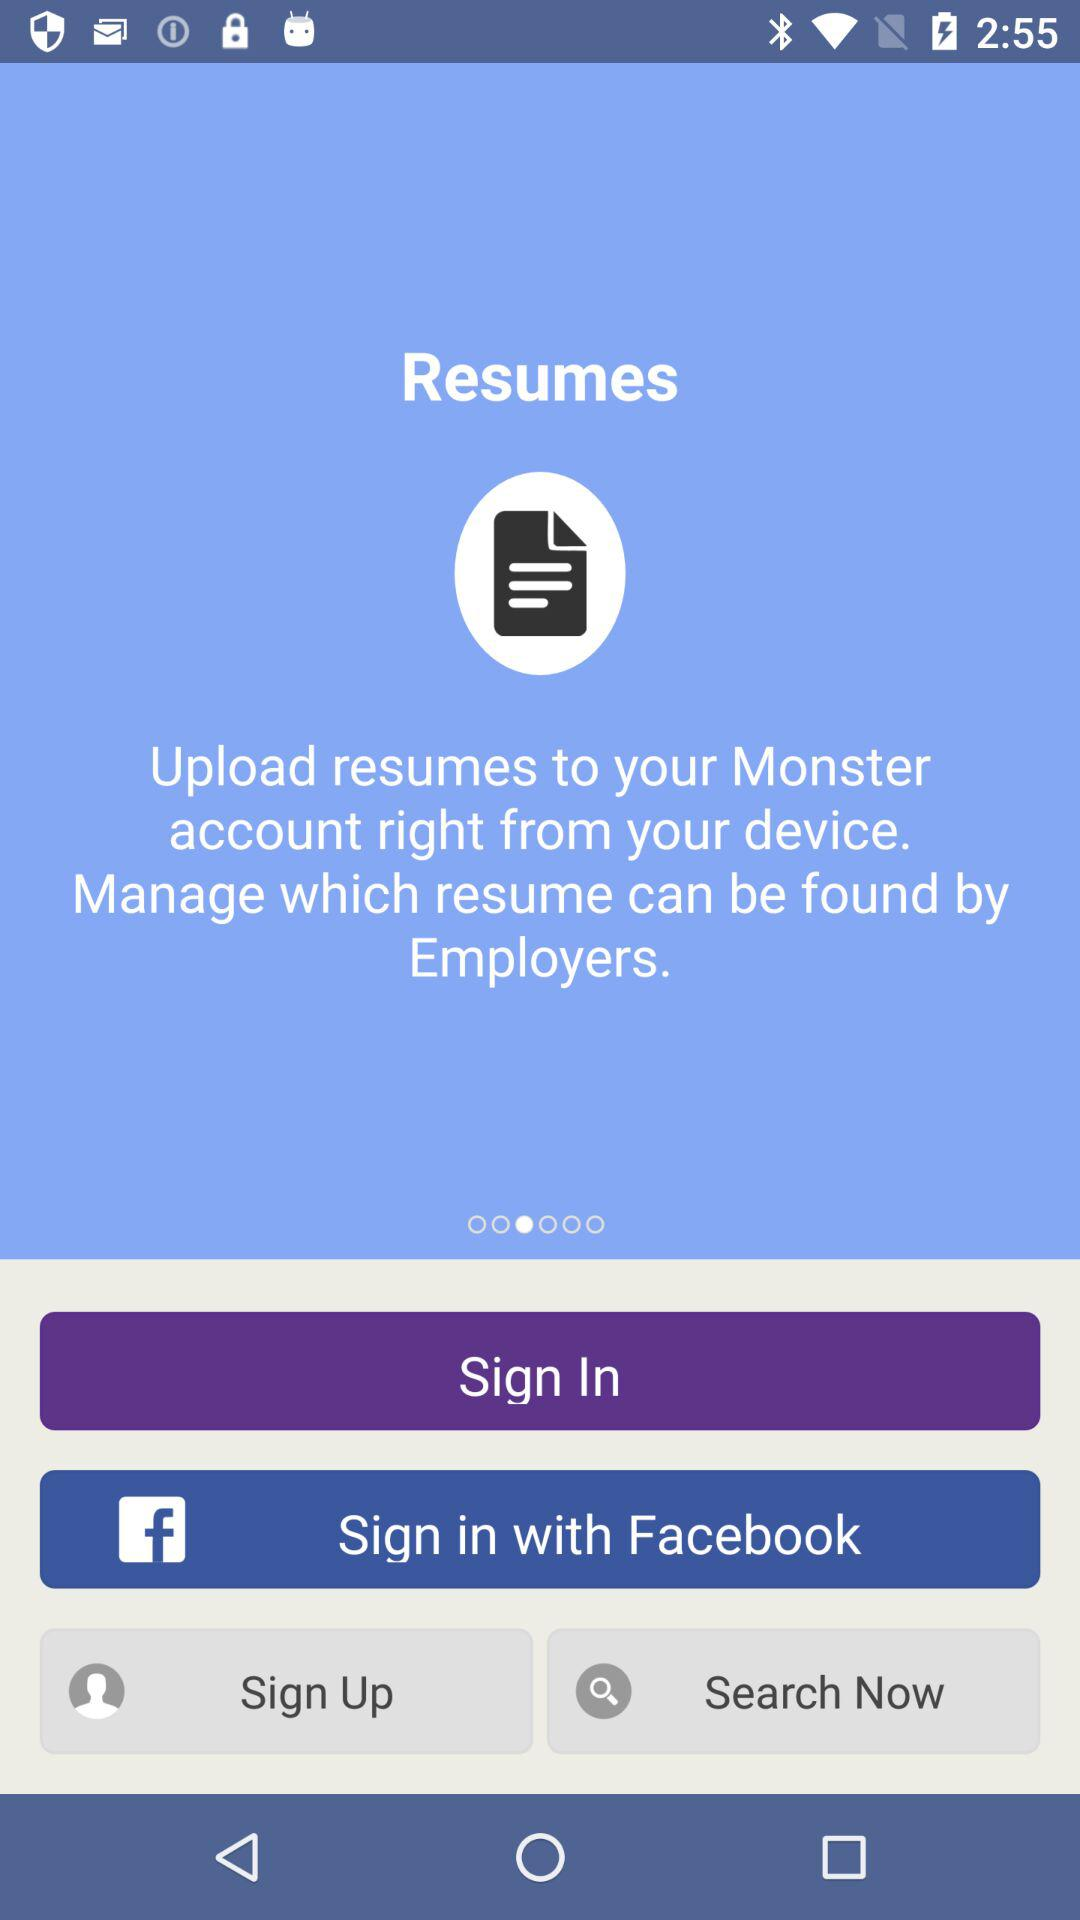Whose resume is it?
When the provided information is insufficient, respond with <no answer>. <no answer> 